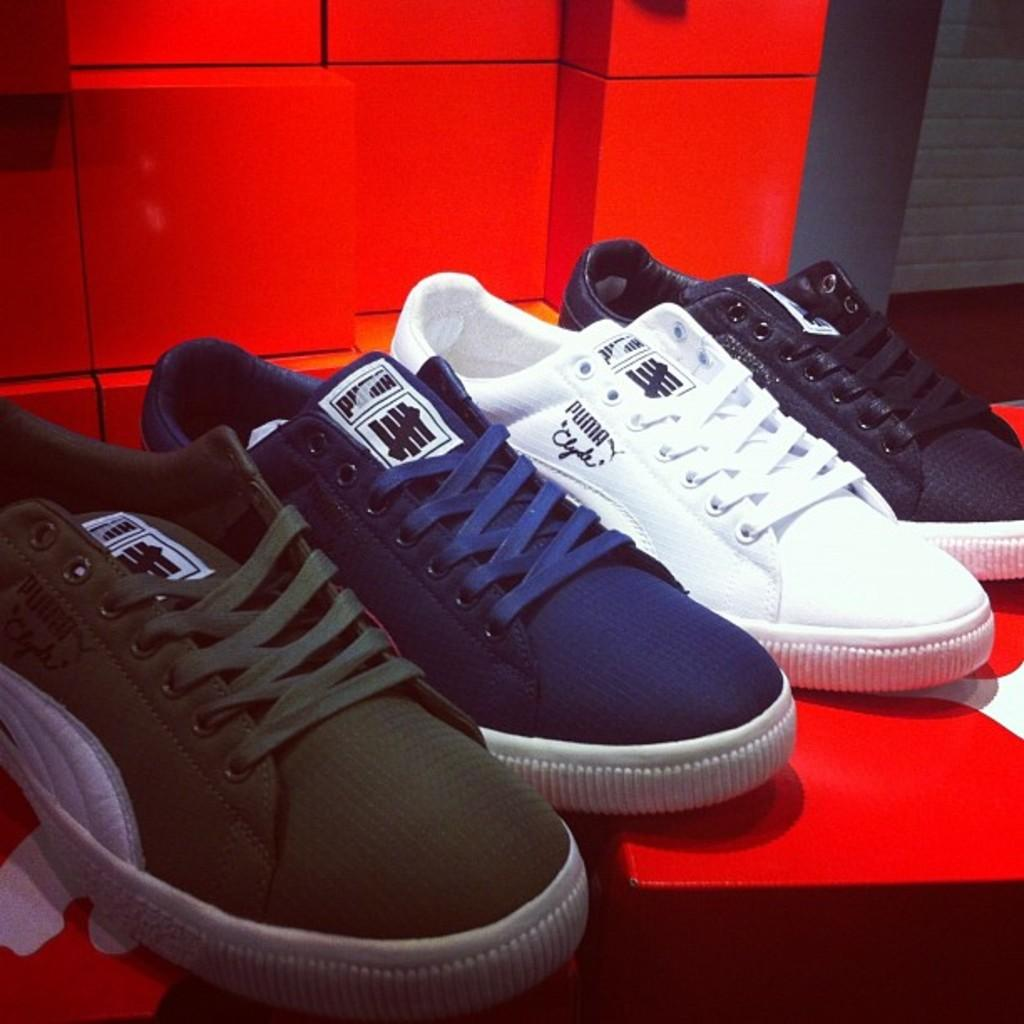What type of footwear is visible in the image? There are shoes in the image. Can you describe the colors of the shoes? The shoes are in different colors. Are there any words or designs on the shoes? Yes, there is text on the shoes. What can be seen in the background of the image? There is a wall in the background of the image. Can you tell me how many snakes are slipping on the shoes in the image? There are no snakes present in the image, and the shoes are not being slipped on. 